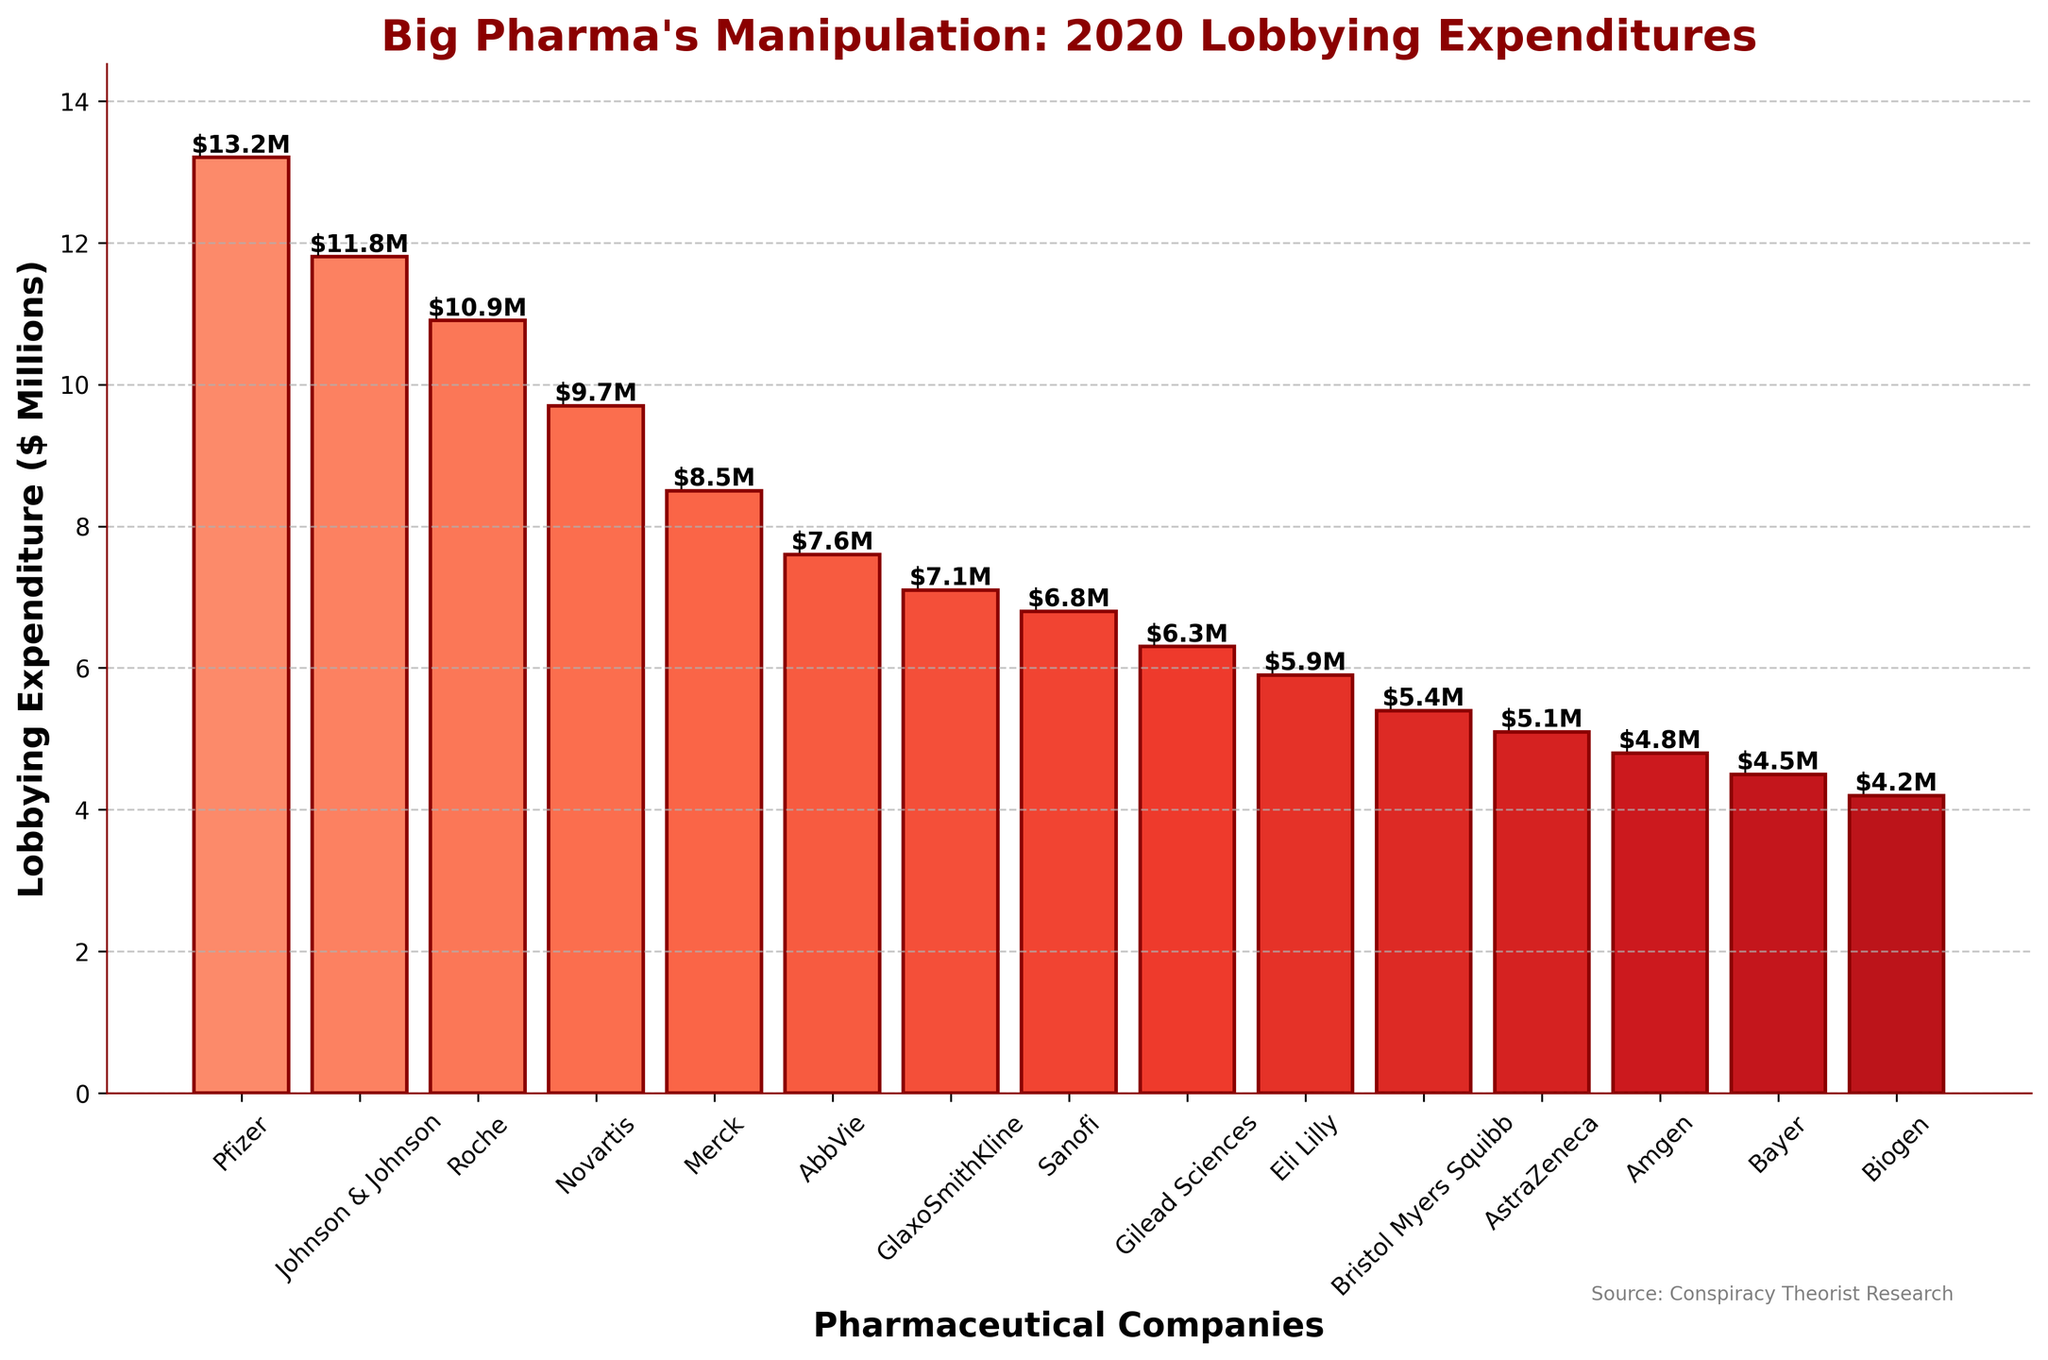What is the total lobbying expenditure of the top three pharmaceutical companies? To find the total expenditure of the top three companies, sum the expenditures of Pfizer ($13.2M), Johnson & Johnson ($11.8M), and Roche ($10.9M). The calculation is 13.2 + 11.8 + 10.9 = $35.9M.
Answer: $35.9M Which company spent the most on lobbying in 2020? Look at the heights of the bars to identify the tallest one. Pfizer has the tallest bar, indicating the highest expenditure at $13.2M.
Answer: Pfizer Which company spent less on lobbying: Amgen or Bayer? Compare the heights of the bars for Amgen and Bayer. Amgen's bar is slightly taller (at $4.8M) compared to Bayer's bar (at $4.5M).
Answer: Bayer How much more did Pfizer spend compared to Eli Lilly? Find the heights of the bars for Pfizer ($13.2M) and Eli Lilly ($5.9M) and subtract the lower expenditure from the higher one. The calculation is 13.2 - 5.9 = $7.3M.
Answer: $7.3M What is the average lobbying expenditure of all the companies listed? Sum all the lobbying expenditures and divide by the number of companies. The sum is 13.2 + 11.8 + 10.9 + 9.7 + 8.5 + 7.6 + 7.1 + 6.8 + 6.3 + 5.9 + 5.4 + 5.1 + 4.8 + 4.5 + 4.2 = $111.8M. The average is 111.8 / 15 = $7.45M.
Answer: $7.45M What companies are identified with the darkest bars, and what might that signify? Darker bars in the color scheme indicate higher expenditures. Pfizer, Johnson & Johnson, and Roche have the darkest bars, signifying the highest lobbying expenditures.
Answer: Pfizer, Johnson & Johnson, Roche How many companies spent more than $10M in lobbying? Count the number of bars that exceed the 10M mark. Pfizer, Johnson & Johnson, and Roche each spent more than $10M.
Answer: 3 Which company's lobbying expenditure is closest to the average of all companies? Calculate the absolute differences between each company's expenditure and the average ($7.45M). Identify the smallest difference. AbbVie's expenditure ($7.6M) is closest to the average.
Answer: AbbVie What is the difference in lobbying expenditure between the company that spent the least and the one that spent the most? Identify the smallest ($4.2M for Biogen) and largest ($13.2M for Pfizer) expenditures. Subtract the smallest from the largest: 13.2 - 4.2 = $9M.
Answer: $9M Which companies fall below the average lobbying expenditure? Calculate the average ($7.45M) and list the companies with expenditures below this amount: Sanofi ($6.8M), Gilead Sciences ($6.3M), Eli Lilly ($5.9M), Bristol Myers Squibb ($5.4M), AstraZeneca ($5.1M), Amgen ($4.8M), Bayer ($4.5M), Biogen ($4.2M).
Answer: Sanofi, Gilead Sciences, Eli Lilly, Bristol Myers Squibb, AstraZeneca, Amgen, Bayer, Biogen 